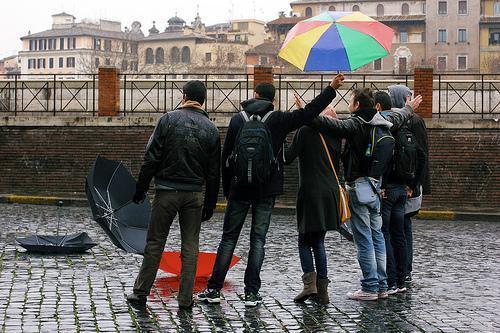How many people are pictured in the photo?
Give a very brief answer. 6. How many umbrellas are lying on the ground?
Give a very brief answer. 2. 